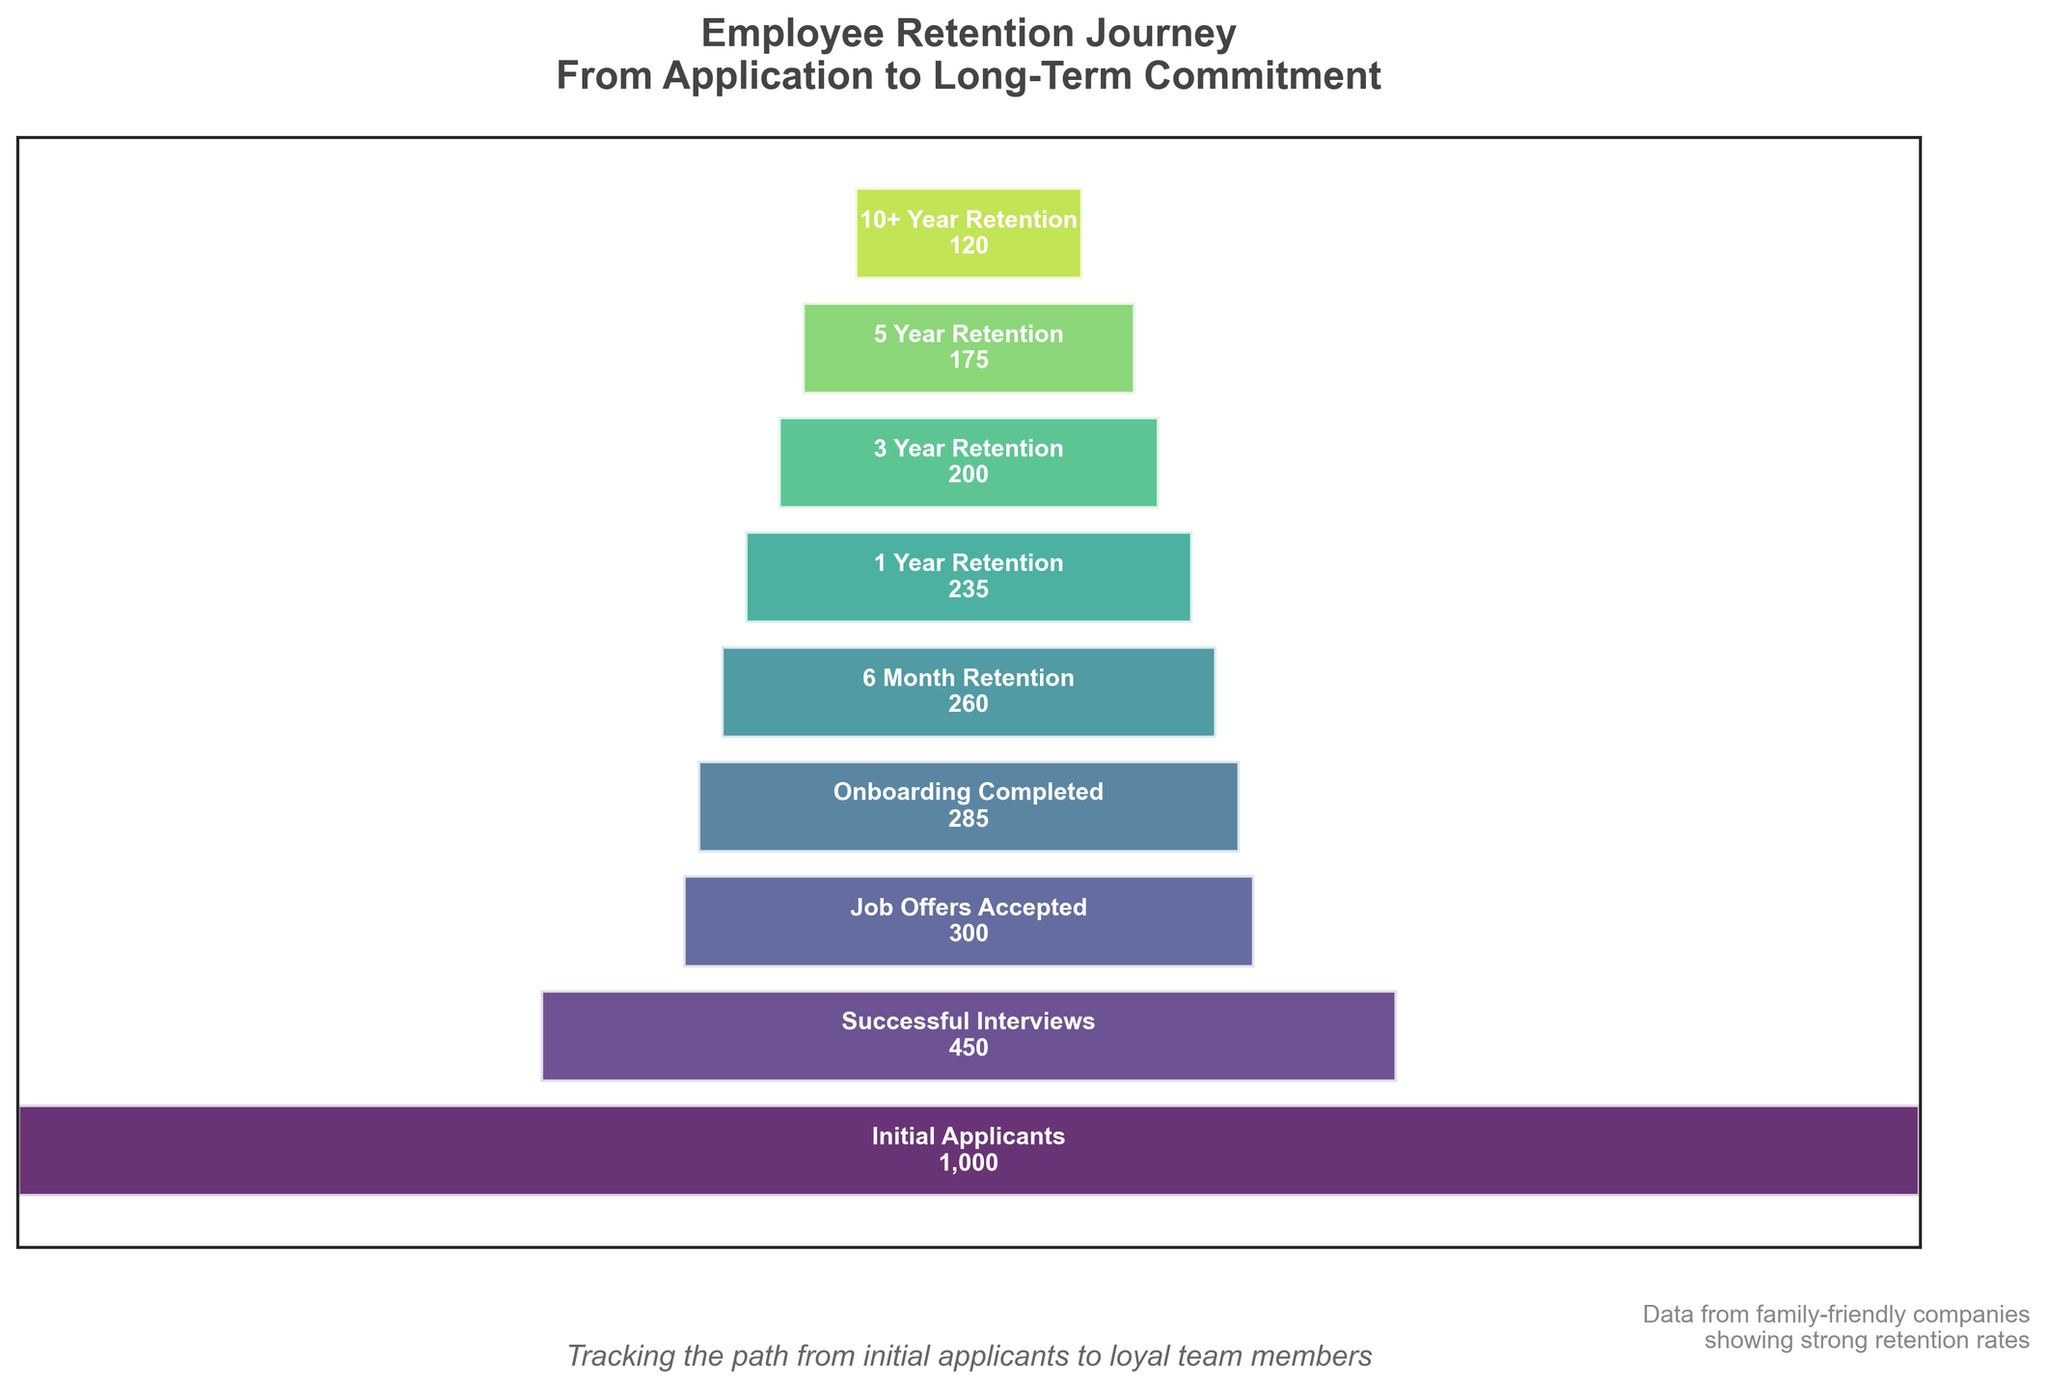What is the total number of initial applicants? The chart shows the number of employees at different stages. The first stage, labeled "Initial Applicants", shows 1,000 employees.
Answer: 1,000 What percentage of initial applicants completed the onboarding stage? There are 1,000 initial applicants and 285 completed the onboarding stage. The percentage is calculated as (285 / 1,000) * 100 = 28.5%.
Answer: 28.5% How many employees retained after 1 year? The chart shows a distinct stage called "1 Year Retention", indicating this stage has 235 employees.
Answer: 235 What is the difference in employee count between 6 Month Retention and 3 Year Retention? The 6 Month Retention stage has 260 employees and the 3 Year Retention stage has 200 employees. The difference is 260 - 200 = 60.
Answer: 60 Which stage has the highest drop in employee count compared to the previous stage? Comparing the drop rates between stages: Initial Applicants to Successful Interviews (550), Successful Interviews to Job Offers Accepted (150), Job Offers Accepted to Onboarding Completed (15), Onboarding Completed to 6 Month Retention (25), 6 Month Retention to 1 Year Retention (25), 1 Year Retention to 3 Year Retention (35), 3 Year Retention to 5 Year Retention (25), 5 Year Retention to 10+ Year Retention (55). The highest drop is between Initial Applicants and Successful Interviews.
Answer: Initial Applicants to Successful Interviews What is the retention rate from onboarding completion to 10+ year retention? The onboarding completed stage has 285 employees, and the 10+ year retention stage has 120 employees. The retention rate is calculated as (120 / 285) * 100 = 42.1%.
Answer: 42.1% How does the retention number trend over the years from 1 Year Retention to 5 Year Retention? The employee count at 1 Year Retention is 235, at 3 Year Retention is 200, and at 5 Year Retention is 175. The trend shows a consistent decline over these periods.
Answer: Consistent decline What stage follows job offers being accepted? Based on the ordering in the chart, the stage directly following "Job Offers Accepted" is "Onboarding Completed".
Answer: Onboarding Completed What is the visual representation (color) trend from the first stage to the last? The colors of the bars transition from lighter shades of green at the Initial Applicants stage to darker shades of green towards the 10+ Year Retention stage.
Answer: Lighter to darker green How many stages show a retention rate greater than 50% from the previous stage? Calculate retention between stages: Initial to Successful Interviews (45%), Interviews to Job Offers (67%), Job Offers to Onboarding (95%), Onboarding to 6 Months (91%), 6 Months to 1 Year (90%), 1 Year to 3 Years (85%), 3 Years to 5 Years (88%), 5 Years to 10+ Years (69%). Out of these, seven stages (Interviews to Job Offers, Job Offers to Onboarding, Onboarding to 6 Months, 6 Months to 1 Year, 1 Year to 3 Years, 3 Years to 5 Years, 5 Years to 10+ Years) have a retention rate greater than 50%.
Answer: Seven 